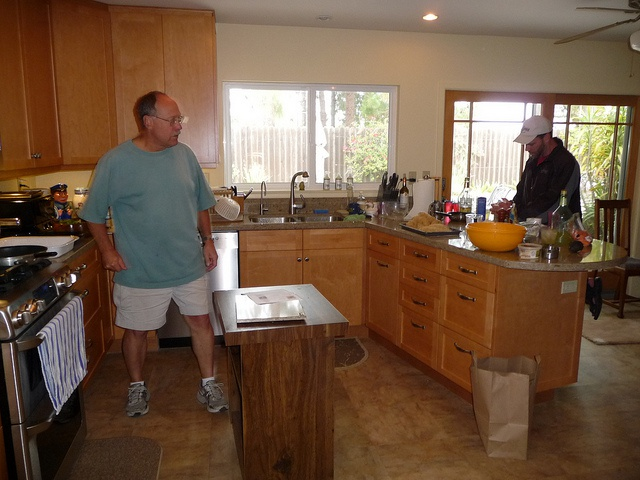Describe the objects in this image and their specific colors. I can see people in maroon, gray, and purple tones, oven in maroon, black, darkgray, and gray tones, people in maroon, black, and gray tones, chair in maroon, black, darkgreen, and gray tones, and bowl in maroon, red, and orange tones in this image. 